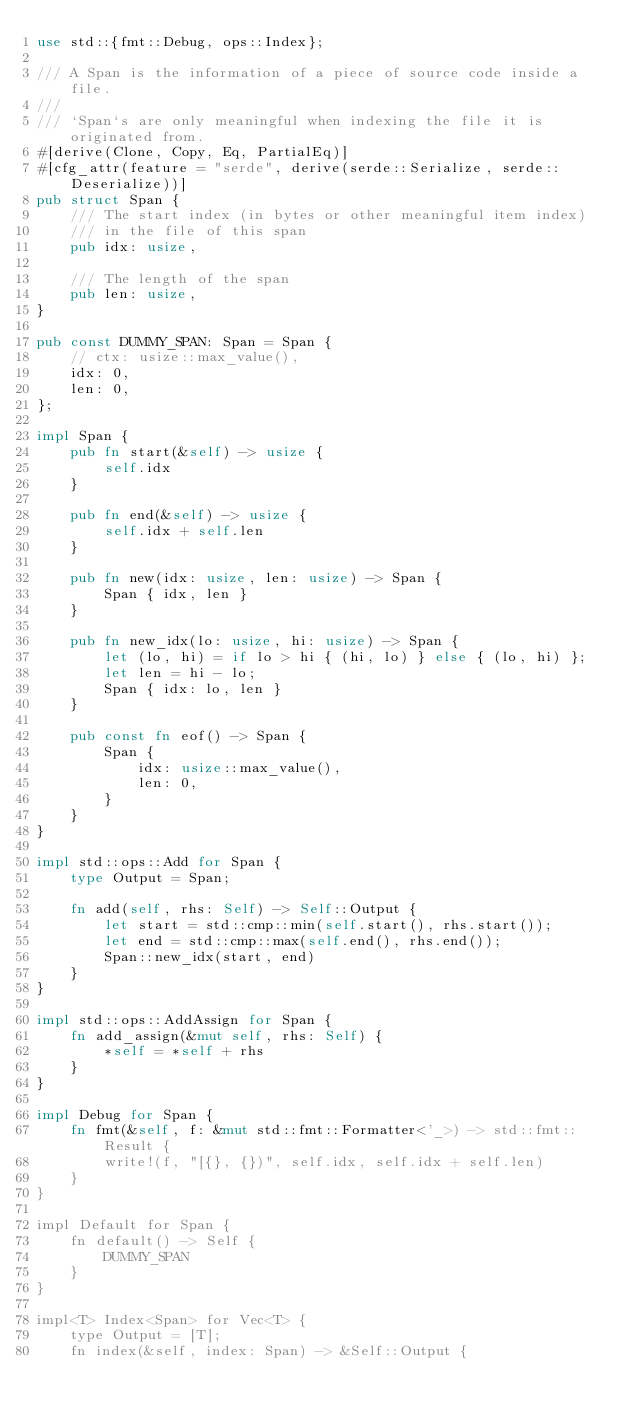<code> <loc_0><loc_0><loc_500><loc_500><_Rust_>use std::{fmt::Debug, ops::Index};

/// A Span is the information of a piece of source code inside a file.
///
/// `Span`s are only meaningful when indexing the file it is originated from.
#[derive(Clone, Copy, Eq, PartialEq)]
#[cfg_attr(feature = "serde", derive(serde::Serialize, serde::Deserialize))]
pub struct Span {
    /// The start index (in bytes or other meaningful item index)
    /// in the file of this span
    pub idx: usize,

    /// The length of the span
    pub len: usize,
}

pub const DUMMY_SPAN: Span = Span {
    // ctx: usize::max_value(),
    idx: 0,
    len: 0,
};

impl Span {
    pub fn start(&self) -> usize {
        self.idx
    }

    pub fn end(&self) -> usize {
        self.idx + self.len
    }

    pub fn new(idx: usize, len: usize) -> Span {
        Span { idx, len }
    }

    pub fn new_idx(lo: usize, hi: usize) -> Span {
        let (lo, hi) = if lo > hi { (hi, lo) } else { (lo, hi) };
        let len = hi - lo;
        Span { idx: lo, len }
    }

    pub const fn eof() -> Span {
        Span {
            idx: usize::max_value(),
            len: 0,
        }
    }
}

impl std::ops::Add for Span {
    type Output = Span;

    fn add(self, rhs: Self) -> Self::Output {
        let start = std::cmp::min(self.start(), rhs.start());
        let end = std::cmp::max(self.end(), rhs.end());
        Span::new_idx(start, end)
    }
}

impl std::ops::AddAssign for Span {
    fn add_assign(&mut self, rhs: Self) {
        *self = *self + rhs
    }
}

impl Debug for Span {
    fn fmt(&self, f: &mut std::fmt::Formatter<'_>) -> std::fmt::Result {
        write!(f, "[{}, {})", self.idx, self.idx + self.len)
    }
}

impl Default for Span {
    fn default() -> Self {
        DUMMY_SPAN
    }
}

impl<T> Index<Span> for Vec<T> {
    type Output = [T];
    fn index(&self, index: Span) -> &Self::Output {</code> 